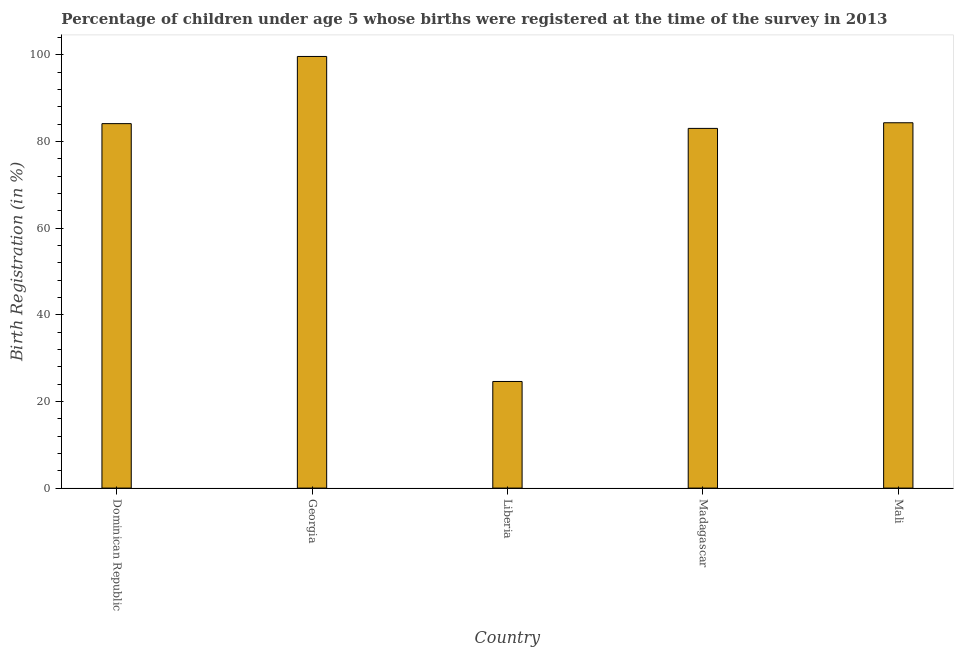What is the title of the graph?
Your answer should be compact. Percentage of children under age 5 whose births were registered at the time of the survey in 2013. What is the label or title of the Y-axis?
Provide a short and direct response. Birth Registration (in %). What is the birth registration in Dominican Republic?
Your answer should be very brief. 84.1. Across all countries, what is the maximum birth registration?
Provide a short and direct response. 99.6. Across all countries, what is the minimum birth registration?
Give a very brief answer. 24.6. In which country was the birth registration maximum?
Your response must be concise. Georgia. In which country was the birth registration minimum?
Make the answer very short. Liberia. What is the sum of the birth registration?
Make the answer very short. 375.6. What is the difference between the birth registration in Liberia and Madagascar?
Ensure brevity in your answer.  -58.4. What is the average birth registration per country?
Provide a succinct answer. 75.12. What is the median birth registration?
Your answer should be very brief. 84.1. In how many countries, is the birth registration greater than 80 %?
Provide a short and direct response. 4. What is the ratio of the birth registration in Georgia to that in Madagascar?
Give a very brief answer. 1.2. Is the birth registration in Dominican Republic less than that in Madagascar?
Your response must be concise. No. Is the difference between the birth registration in Dominican Republic and Liberia greater than the difference between any two countries?
Provide a short and direct response. No. What is the difference between the highest and the second highest birth registration?
Your response must be concise. 15.3. Is the sum of the birth registration in Liberia and Madagascar greater than the maximum birth registration across all countries?
Keep it short and to the point. Yes. What is the difference between the highest and the lowest birth registration?
Give a very brief answer. 75. In how many countries, is the birth registration greater than the average birth registration taken over all countries?
Offer a terse response. 4. How many bars are there?
Provide a short and direct response. 5. Are all the bars in the graph horizontal?
Your answer should be compact. No. What is the difference between two consecutive major ticks on the Y-axis?
Offer a very short reply. 20. What is the Birth Registration (in %) of Dominican Republic?
Offer a very short reply. 84.1. What is the Birth Registration (in %) in Georgia?
Offer a terse response. 99.6. What is the Birth Registration (in %) of Liberia?
Ensure brevity in your answer.  24.6. What is the Birth Registration (in %) in Madagascar?
Your response must be concise. 83. What is the Birth Registration (in %) in Mali?
Your response must be concise. 84.3. What is the difference between the Birth Registration (in %) in Dominican Republic and Georgia?
Your answer should be compact. -15.5. What is the difference between the Birth Registration (in %) in Dominican Republic and Liberia?
Offer a terse response. 59.5. What is the difference between the Birth Registration (in %) in Dominican Republic and Madagascar?
Your response must be concise. 1.1. What is the difference between the Birth Registration (in %) in Dominican Republic and Mali?
Provide a short and direct response. -0.2. What is the difference between the Birth Registration (in %) in Georgia and Liberia?
Give a very brief answer. 75. What is the difference between the Birth Registration (in %) in Liberia and Madagascar?
Your answer should be compact. -58.4. What is the difference between the Birth Registration (in %) in Liberia and Mali?
Ensure brevity in your answer.  -59.7. What is the ratio of the Birth Registration (in %) in Dominican Republic to that in Georgia?
Give a very brief answer. 0.84. What is the ratio of the Birth Registration (in %) in Dominican Republic to that in Liberia?
Make the answer very short. 3.42. What is the ratio of the Birth Registration (in %) in Georgia to that in Liberia?
Give a very brief answer. 4.05. What is the ratio of the Birth Registration (in %) in Georgia to that in Mali?
Your answer should be compact. 1.18. What is the ratio of the Birth Registration (in %) in Liberia to that in Madagascar?
Keep it short and to the point. 0.3. What is the ratio of the Birth Registration (in %) in Liberia to that in Mali?
Give a very brief answer. 0.29. What is the ratio of the Birth Registration (in %) in Madagascar to that in Mali?
Make the answer very short. 0.98. 